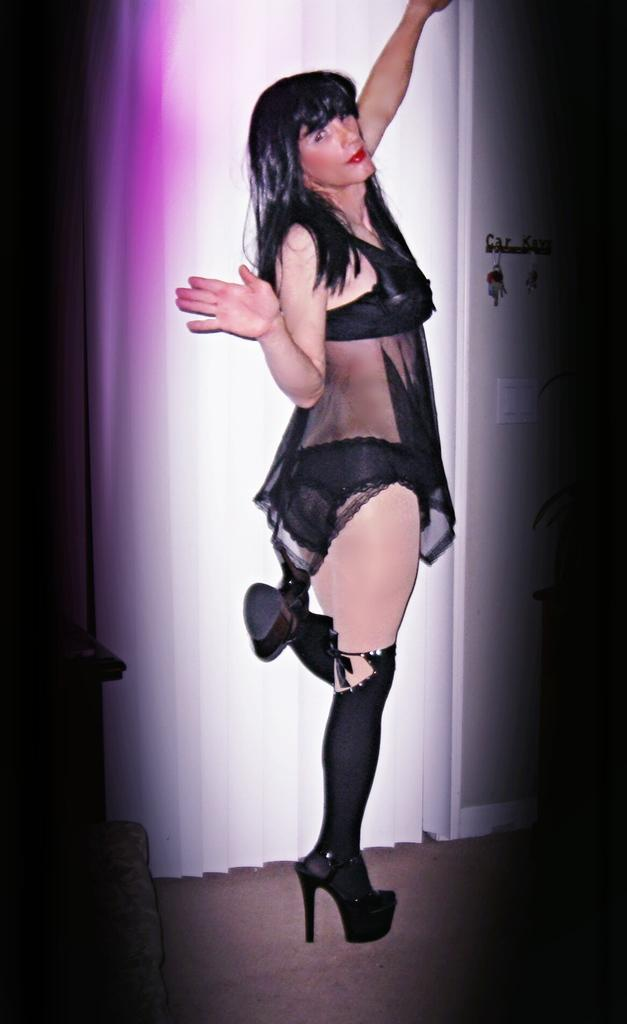What is the main subject of the image? There is a woman standing in the image. Where is the woman standing? The woman is standing on the floor. What can be seen in the background of the image? There is a curtain and a door in the background of the image. What is attached to the door in the background? There is a key holder attached to the door in the background of the image. Can you hear the woman laughing in the image? There is no indication of laughter or sound in the image, so it cannot be determined from the image alone. 